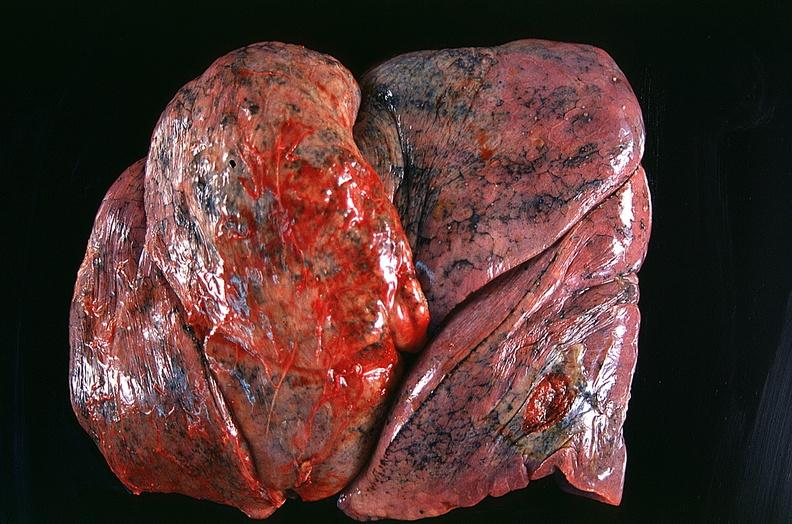where is this?
Answer the question using a single word or phrase. Lung 